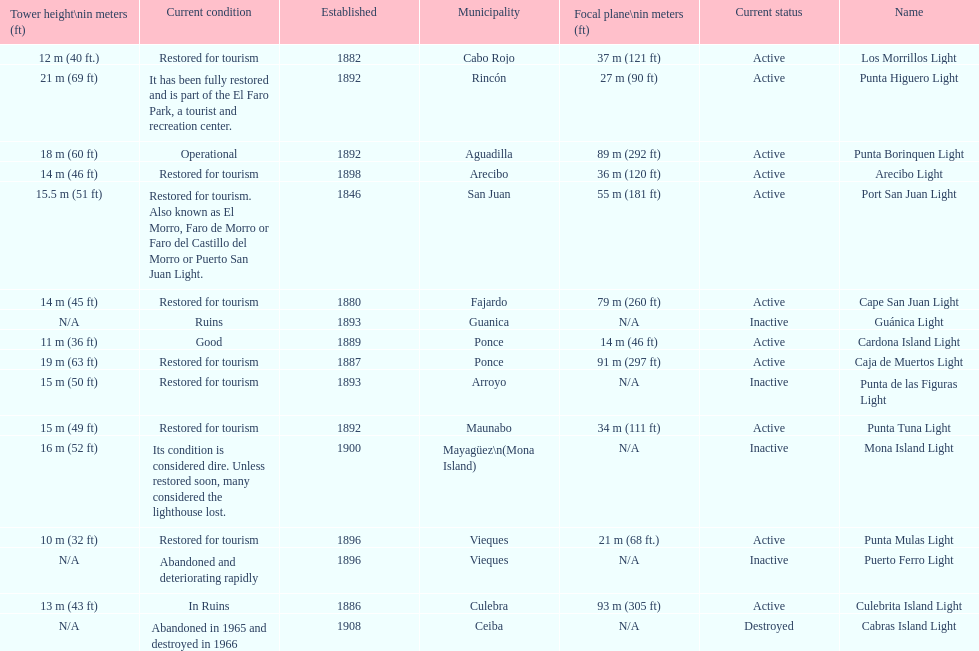The difference in years from 1882 to 1889 7. 